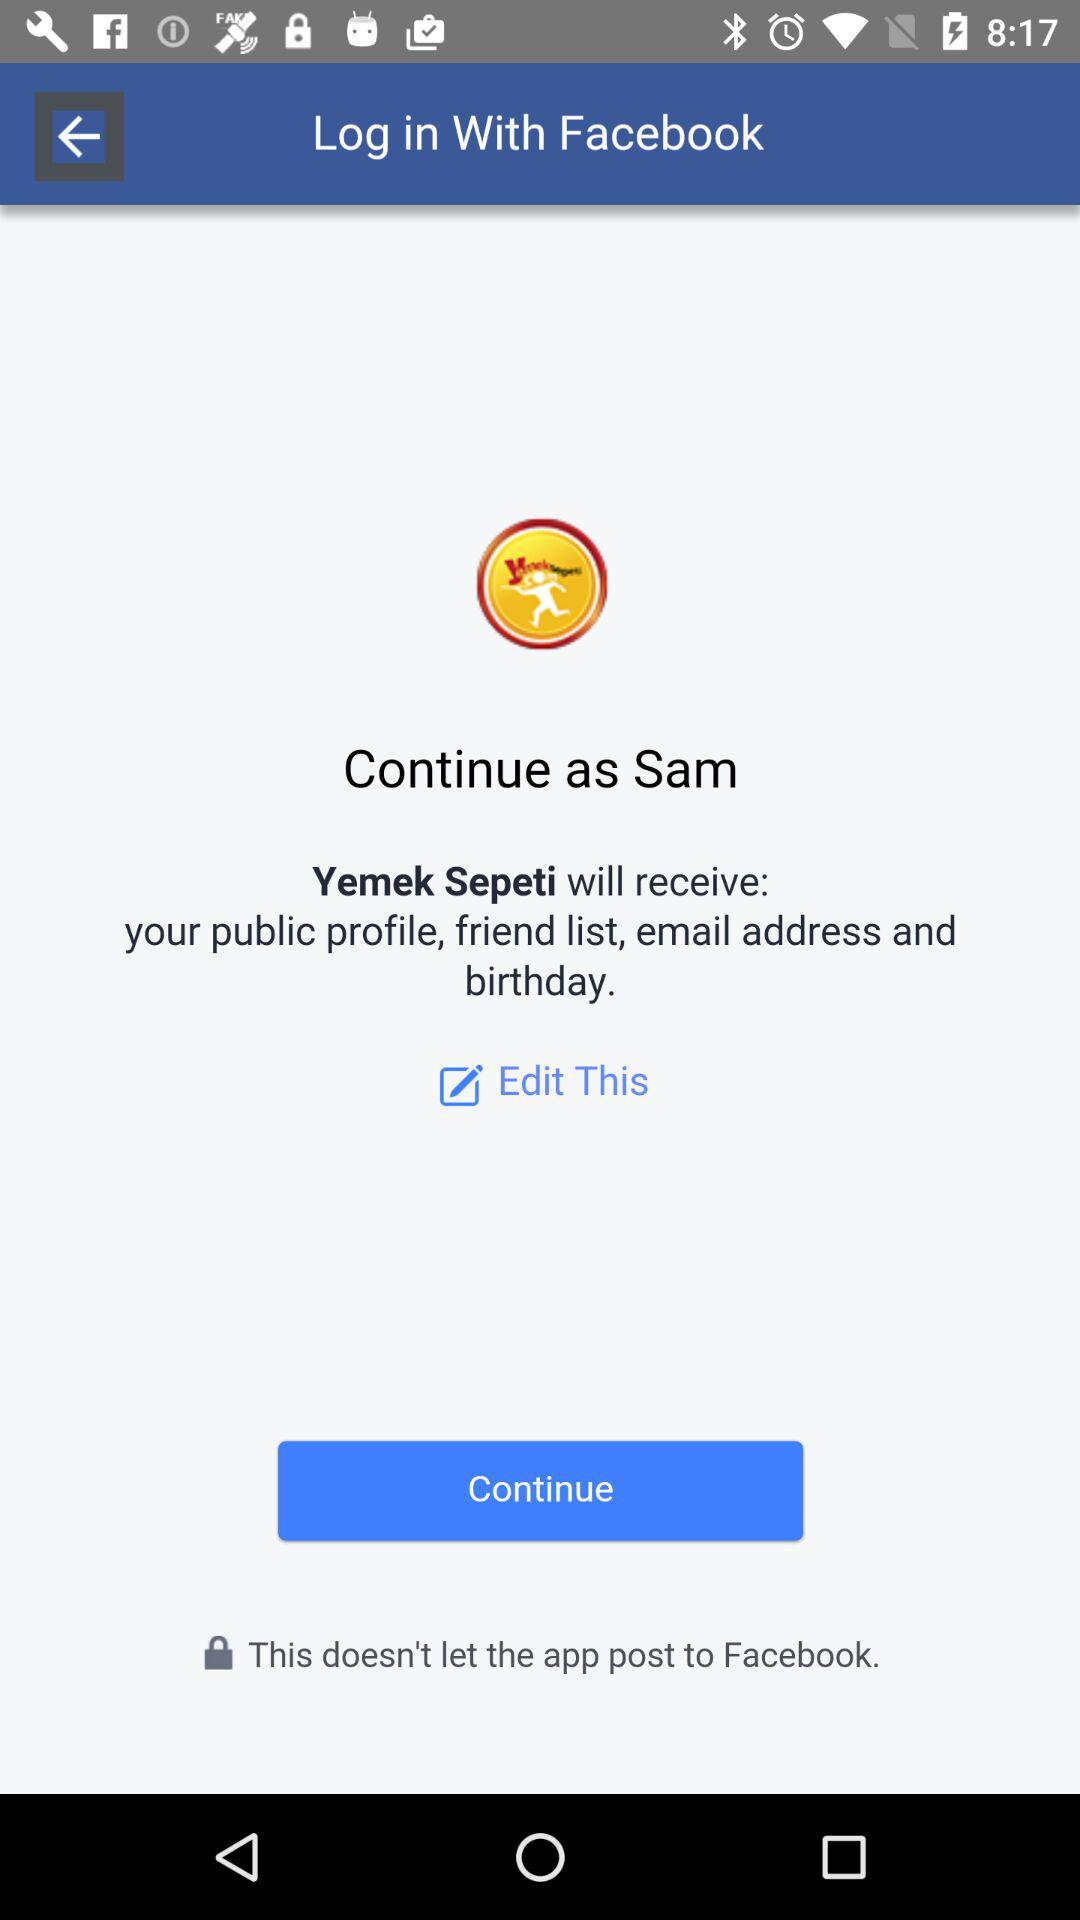What is the name of the application? The names of the applications are "Yemek Sepeti" and "Facebook". 